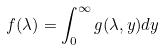<formula> <loc_0><loc_0><loc_500><loc_500>f ( \lambda ) = \int _ { 0 } ^ { \infty } g ( \lambda , y ) d y</formula> 